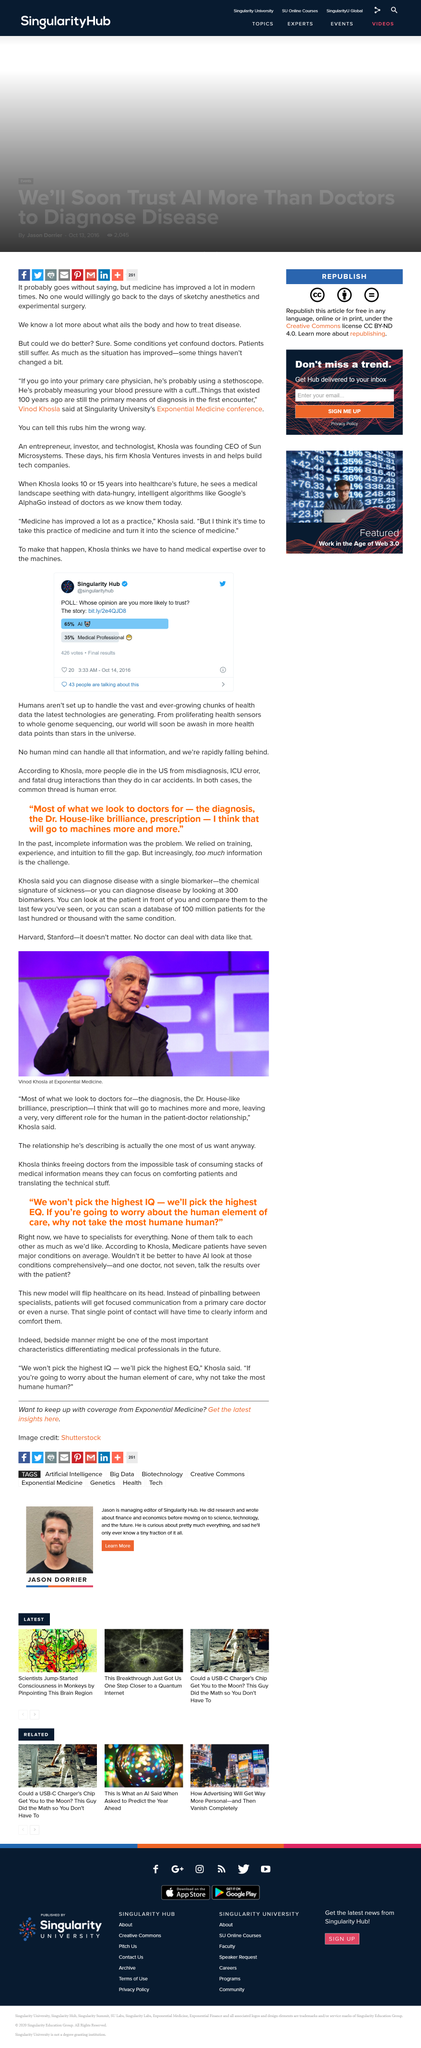Draw attention to some important aspects in this diagram. It is possible to diagnose a disease with a single biomarker. Yes, Vivek Khosla believes that medical expertise must be handed over to machines. The photograph depicts Vinod Khosla. The diagnosis and prescription tasks typically performed by doctors will increasingly be taken over by machines in the future. In the foreseeable future, healthcare will be transformed by data-hungry intelligent algorithms, such as Google's AlphaGo, replacing traditional doctors and physicians. 